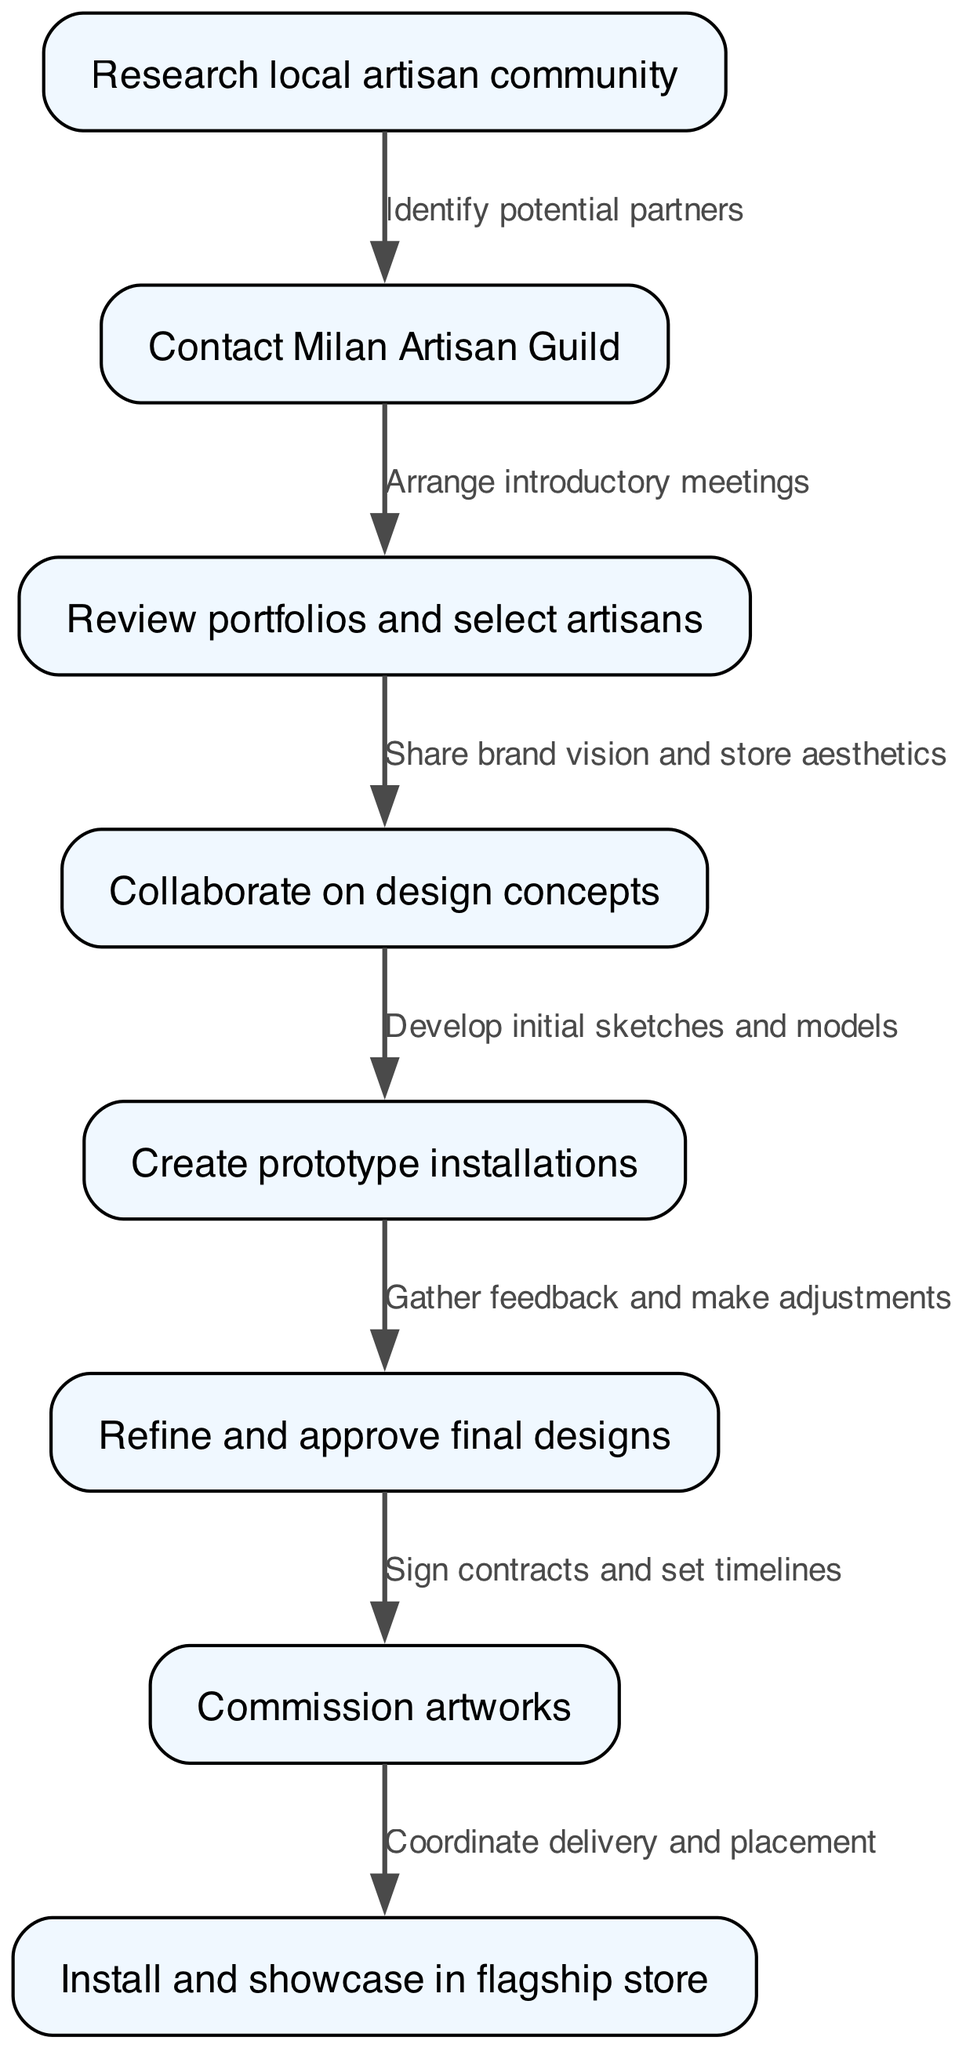What is the first step in the pathway? The first step denotes the initial action taken in the process, which involves researching the local artisan community. This is found directly at the top of the diagram, representing the starting point.
Answer: Research local artisan community How many nodes are in the diagram? By counting each of the distinct steps or points within the diagram, we identify a total of eight individual nodes, each representing a specific part of the pathway.
Answer: 8 What is the final step in the collaboration process? The last node illustrates the culmination of the project, which involves the installation and showcasing of the artworks in the flagship store. This indicates the endpoint of the collaboration pathway.
Answer: Install and showcase in flagship store Which nodes are directly connected to "Collaborate on design concepts"? To determine the connections, we look for edges originating from the node labeled "Collaborate on design concepts." It connects directly to "Create prototype installations," indicating a transitional step in the collaboration process.
Answer: Create prototype installations What task follows after creating prototype installations? After creating the prototypes, the subsequent task is to gather feedback and make adjustments. This is a logical step in refining the concepts before final approval, illustrated by the directed edge from the prototype step in the diagram.
Answer: Gather feedback and make adjustments What does 'Commission artworks' involve after final designs are approved? Once the final designs are approved, commissioning artworks refers to formally procuring the pieces that will be used for the store installations. This signifies a commitment to the agreed-upon designs and involves setting timelines and contracts, as indicated in the flow.
Answer: Sign contracts and set timelines How does "Contact Milan Artisan Guild" relate to "Research local artisan community"? The relationship here is sequential; contacting the guild is the next step after researching the local artisan community, as indicated by the directed edge connecting these two nodes. This shows that identifying potential partners follows after community research.
Answer: Identify potential partners What process is represented between "Refine and approve final designs" and "Commission artworks"? The process represented by the edge between these two nodes involves formalizing agreements and timelines after final designs have been perfected. This is crucial for moving from conceptual designs to actual production.
Answer: Sign contracts and set timelines 